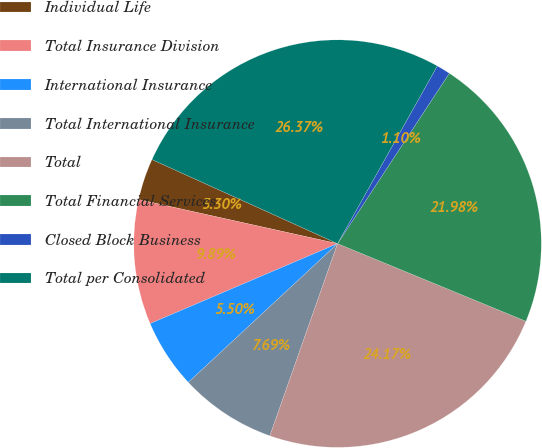Convert chart to OTSL. <chart><loc_0><loc_0><loc_500><loc_500><pie_chart><fcel>Individual Life<fcel>Total Insurance Division<fcel>International Insurance<fcel>Total International Insurance<fcel>Total<fcel>Total Financial Services<fcel>Closed Block Business<fcel>Total per Consolidated<nl><fcel>3.3%<fcel>9.89%<fcel>5.5%<fcel>7.69%<fcel>24.17%<fcel>21.98%<fcel>1.1%<fcel>26.37%<nl></chart> 